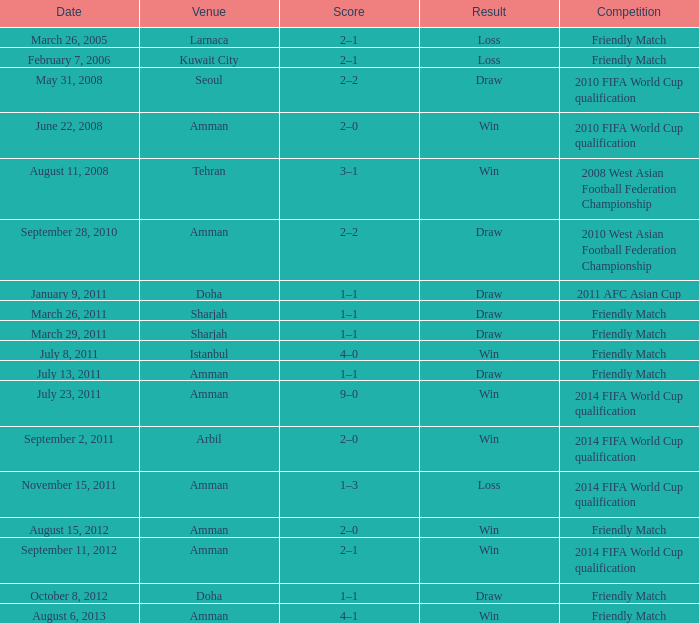Write the full table. {'header': ['Date', 'Venue', 'Score', 'Result', 'Competition'], 'rows': [['March 26, 2005', 'Larnaca', '2–1', 'Loss', 'Friendly Match'], ['February 7, 2006', 'Kuwait City', '2–1', 'Loss', 'Friendly Match'], ['May 31, 2008', 'Seoul', '2–2', 'Draw', '2010 FIFA World Cup qualification'], ['June 22, 2008', 'Amman', '2–0', 'Win', '2010 FIFA World Cup qualification'], ['August 11, 2008', 'Tehran', '3–1', 'Win', '2008 West Asian Football Federation Championship'], ['September 28, 2010', 'Amman', '2–2', 'Draw', '2010 West Asian Football Federation Championship'], ['January 9, 2011', 'Doha', '1–1', 'Draw', '2011 AFC Asian Cup'], ['March 26, 2011', 'Sharjah', '1–1', 'Draw', 'Friendly Match'], ['March 29, 2011', 'Sharjah', '1–1', 'Draw', 'Friendly Match'], ['July 8, 2011', 'Istanbul', '4–0', 'Win', 'Friendly Match'], ['July 13, 2011', 'Amman', '1–1', 'Draw', 'Friendly Match'], ['July 23, 2011', 'Amman', '9–0', 'Win', '2014 FIFA World Cup qualification'], ['September 2, 2011', 'Arbil', '2–0', 'Win', '2014 FIFA World Cup qualification'], ['November 15, 2011', 'Amman', '1–3', 'Loss', '2014 FIFA World Cup qualification'], ['August 15, 2012', 'Amman', '2–0', 'Win', 'Friendly Match'], ['September 11, 2012', 'Amman', '2–1', 'Win', '2014 FIFA World Cup qualification'], ['October 8, 2012', 'Doha', '1–1', 'Draw', 'Friendly Match'], ['August 6, 2013', 'Amman', '4–1', 'Win', 'Friendly Match']]} WHat was the result of the friendly match that was played on october 8, 2012? Draw. 